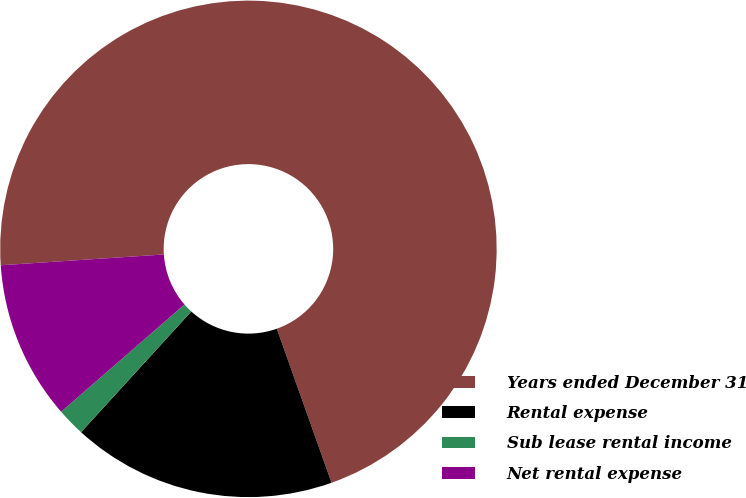<chart> <loc_0><loc_0><loc_500><loc_500><pie_chart><fcel>Years ended December 31<fcel>Rental expense<fcel>Sub lease rental income<fcel>Net rental expense<nl><fcel>70.62%<fcel>17.21%<fcel>1.83%<fcel>10.34%<nl></chart> 